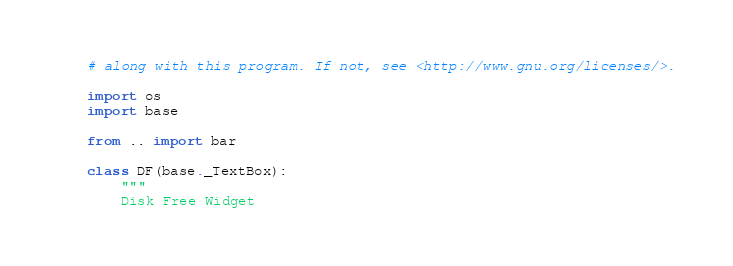<code> <loc_0><loc_0><loc_500><loc_500><_Python_># along with this program. If not, see <http://www.gnu.org/licenses/>.

import os
import base

from .. import bar

class DF(base._TextBox):
    """
    Disk Free Widget
</code> 